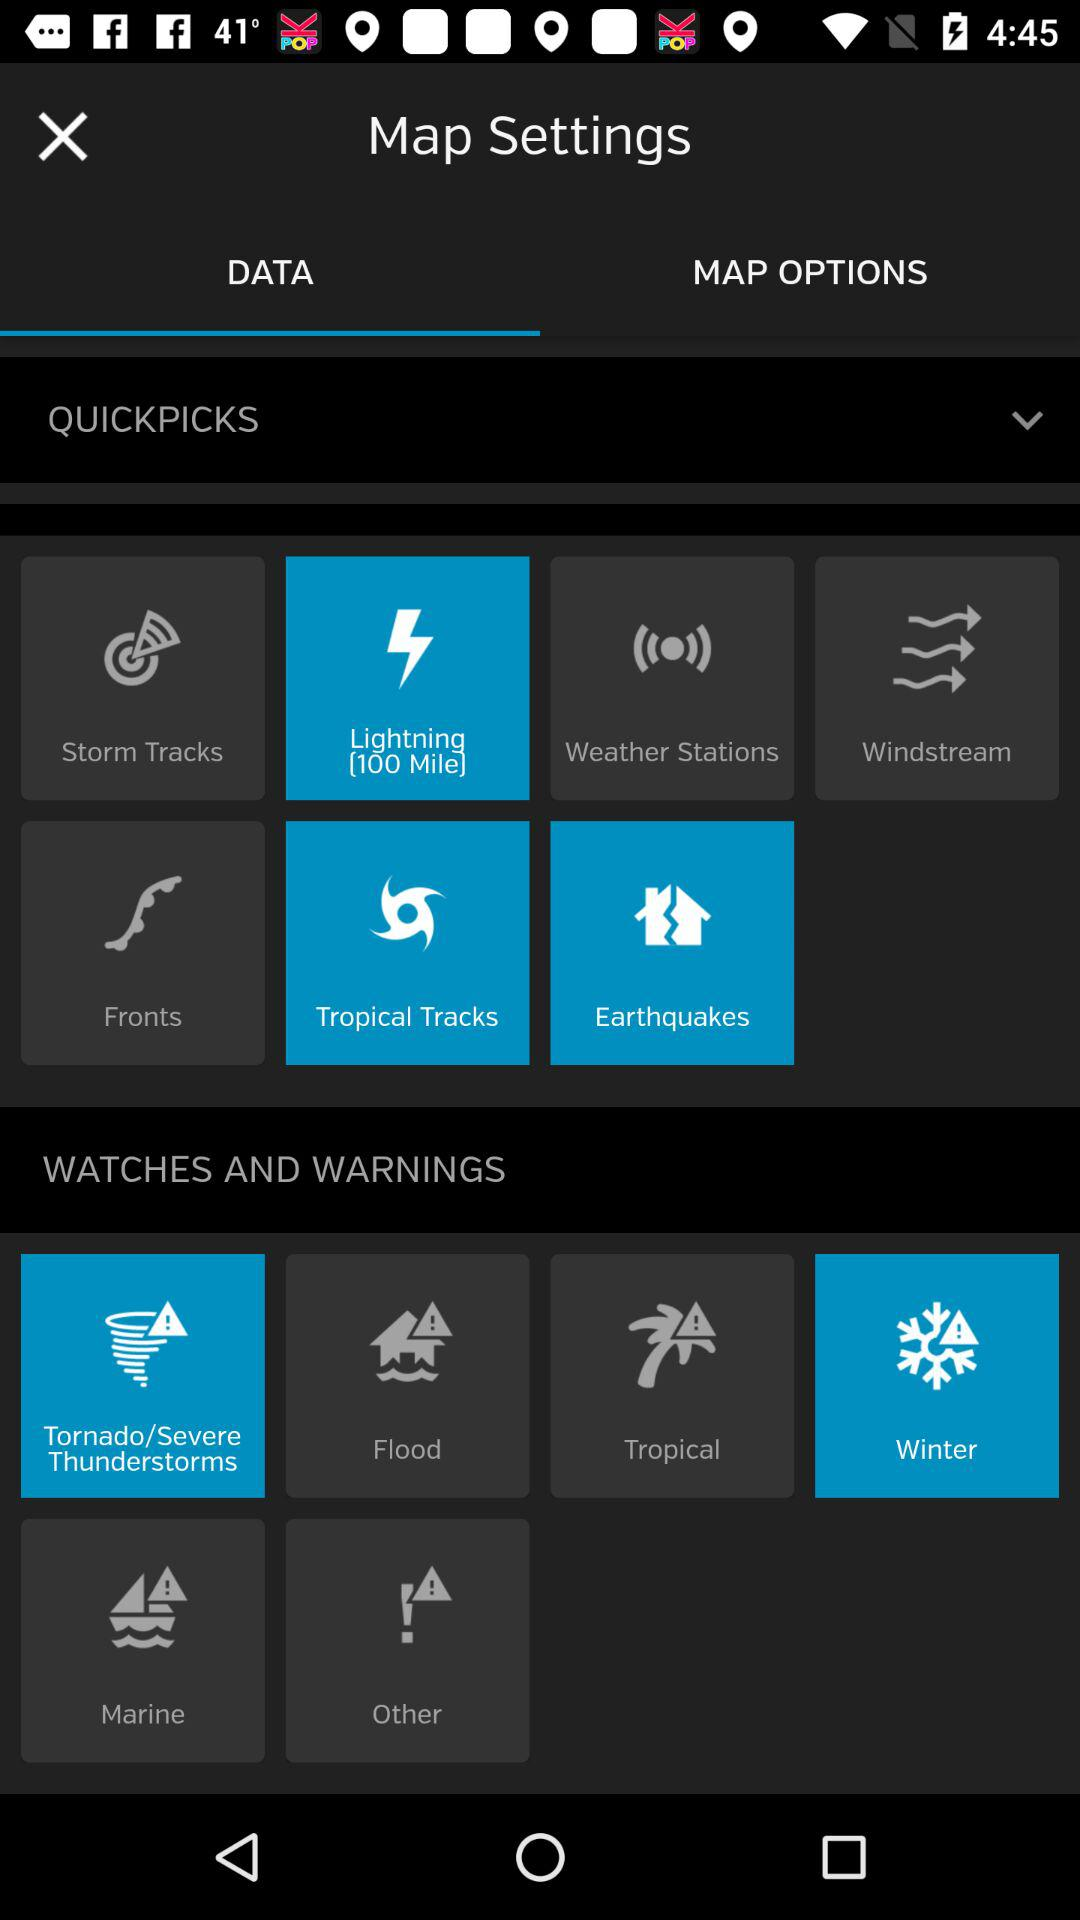Which options are selected in "WATCHES AND WARNINGS"? The selected options in "WATCHES AND WARNINGS" are "Tornado/Severe Thunderstorms" and "Winter". 